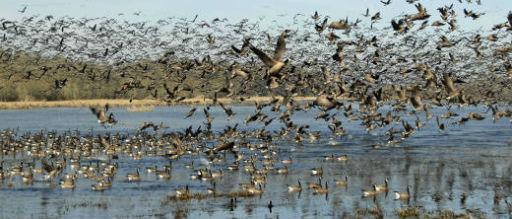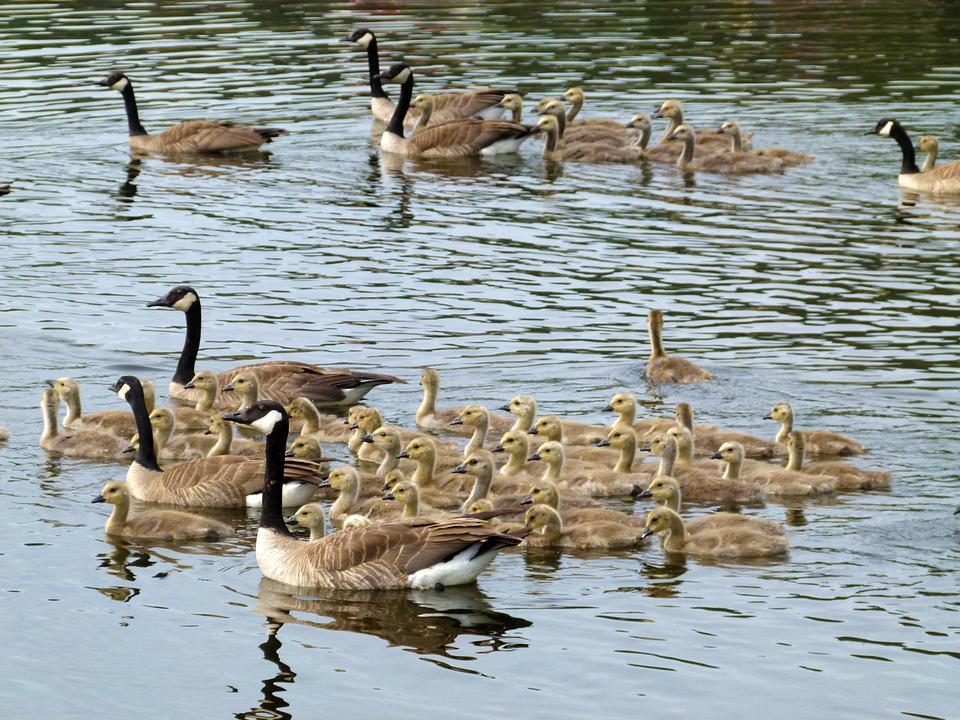The first image is the image on the left, the second image is the image on the right. Evaluate the accuracy of this statement regarding the images: "There are no more than 22 birds in one of the images.". Is it true? Answer yes or no. No. The first image is the image on the left, the second image is the image on the right. For the images displayed, is the sentence "In one image, only birds and sky are visible." factually correct? Answer yes or no. No. 